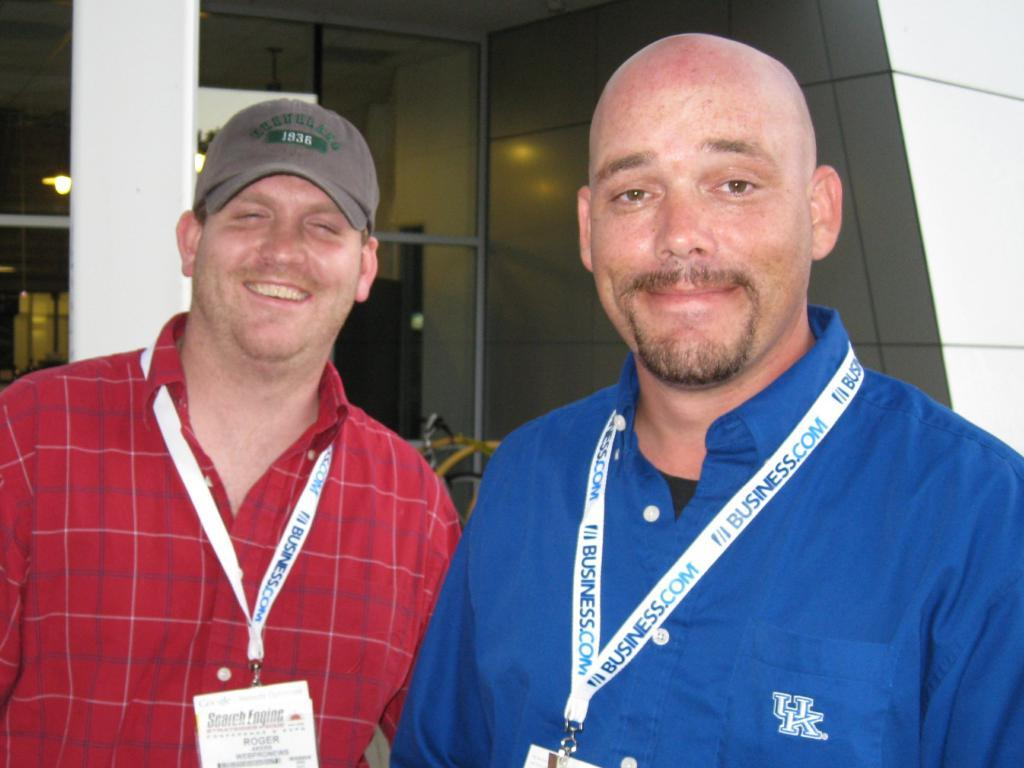Provide a one-sentence caption for the provided image. The man on the right wears a blue shirt from UK. 